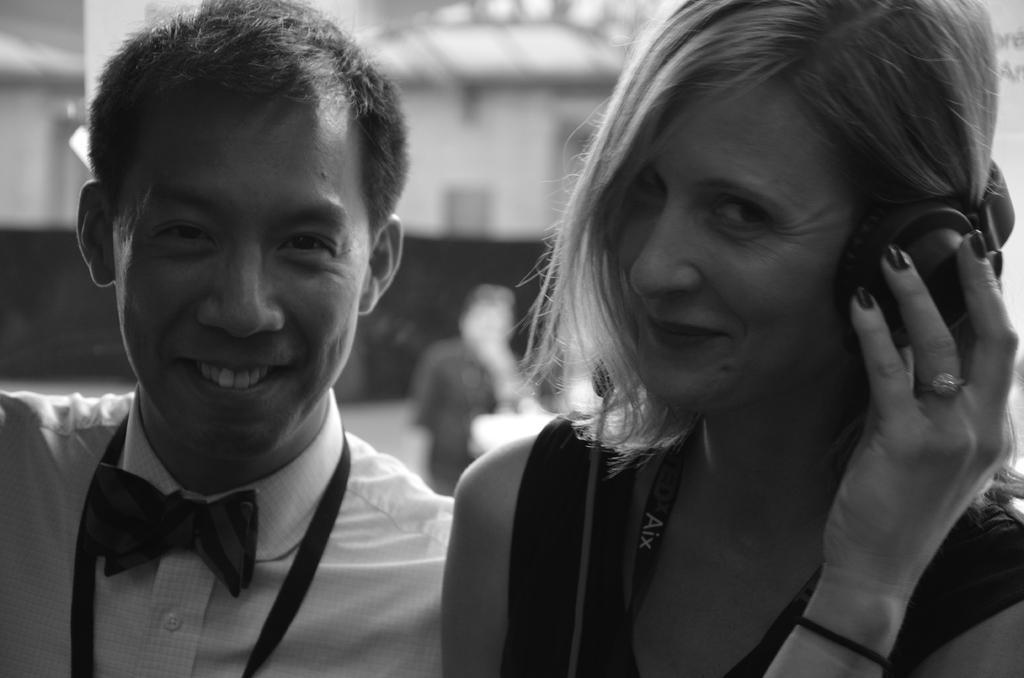Could you give a brief overview of what you see in this image? Here we can see a man and a woman and they are smiling. She wore a headset. There is a blur background. We can see a person and wall. 